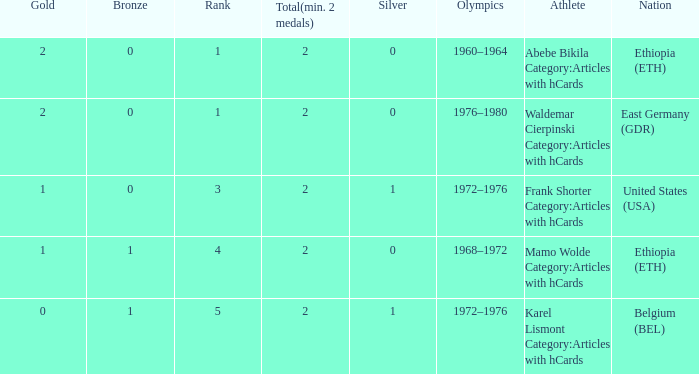What is the least amount of total medals won? 2.0. 